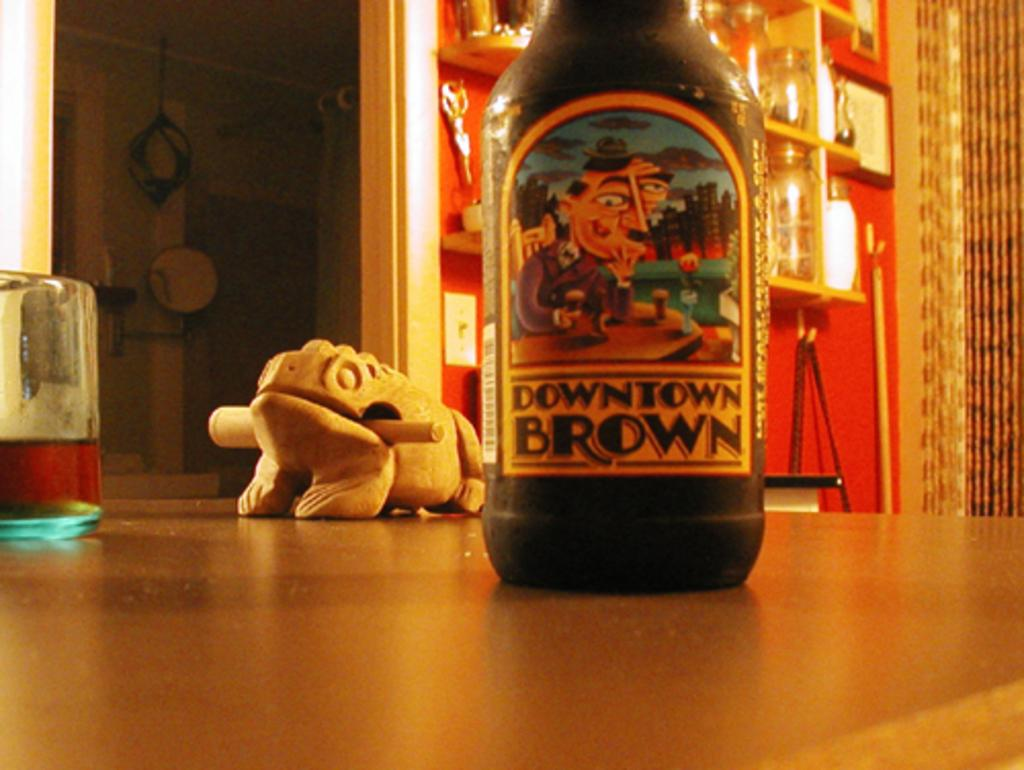<image>
Present a compact description of the photo's key features. Downtown Brown bottle is sitting on a surface with a chameleon sculpture. 